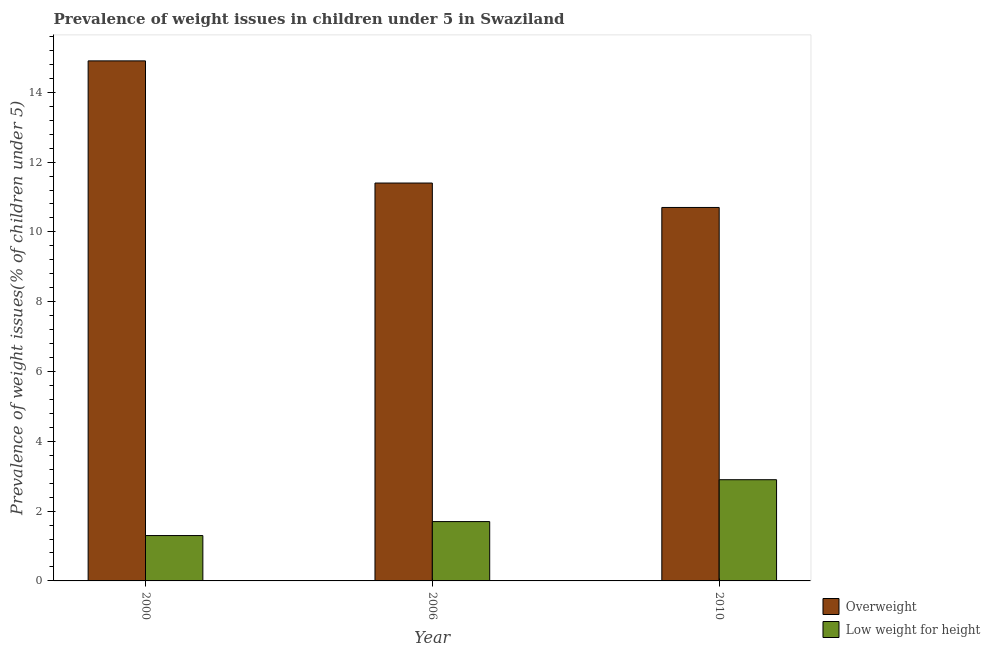How many groups of bars are there?
Offer a terse response. 3. How many bars are there on the 1st tick from the left?
Offer a very short reply. 2. In how many cases, is the number of bars for a given year not equal to the number of legend labels?
Your answer should be compact. 0. What is the percentage of underweight children in 2006?
Your response must be concise. 1.7. Across all years, what is the maximum percentage of underweight children?
Give a very brief answer. 2.9. Across all years, what is the minimum percentage of overweight children?
Give a very brief answer. 10.7. What is the total percentage of underweight children in the graph?
Keep it short and to the point. 5.9. What is the difference between the percentage of overweight children in 2000 and that in 2010?
Keep it short and to the point. 4.2. What is the difference between the percentage of overweight children in 2010 and the percentage of underweight children in 2006?
Your answer should be compact. -0.7. What is the average percentage of overweight children per year?
Provide a short and direct response. 12.33. In how many years, is the percentage of underweight children greater than 10 %?
Offer a very short reply. 0. What is the ratio of the percentage of underweight children in 2006 to that in 2010?
Give a very brief answer. 0.59. Is the percentage of underweight children in 2000 less than that in 2010?
Provide a succinct answer. Yes. Is the difference between the percentage of underweight children in 2000 and 2006 greater than the difference between the percentage of overweight children in 2000 and 2006?
Give a very brief answer. No. What is the difference between the highest and the second highest percentage of underweight children?
Your answer should be compact. 1.2. What is the difference between the highest and the lowest percentage of underweight children?
Provide a succinct answer. 1.6. Is the sum of the percentage of overweight children in 2006 and 2010 greater than the maximum percentage of underweight children across all years?
Your answer should be compact. Yes. What does the 2nd bar from the left in 2000 represents?
Your response must be concise. Low weight for height. What does the 2nd bar from the right in 2010 represents?
Your response must be concise. Overweight. Are all the bars in the graph horizontal?
Make the answer very short. No. How many years are there in the graph?
Your answer should be compact. 3. What is the difference between two consecutive major ticks on the Y-axis?
Make the answer very short. 2. Where does the legend appear in the graph?
Your answer should be very brief. Bottom right. How are the legend labels stacked?
Offer a terse response. Vertical. What is the title of the graph?
Your response must be concise. Prevalence of weight issues in children under 5 in Swaziland. What is the label or title of the Y-axis?
Ensure brevity in your answer.  Prevalence of weight issues(% of children under 5). What is the Prevalence of weight issues(% of children under 5) in Overweight in 2000?
Offer a very short reply. 14.9. What is the Prevalence of weight issues(% of children under 5) of Low weight for height in 2000?
Ensure brevity in your answer.  1.3. What is the Prevalence of weight issues(% of children under 5) in Overweight in 2006?
Give a very brief answer. 11.4. What is the Prevalence of weight issues(% of children under 5) of Low weight for height in 2006?
Your answer should be compact. 1.7. What is the Prevalence of weight issues(% of children under 5) in Overweight in 2010?
Offer a very short reply. 10.7. What is the Prevalence of weight issues(% of children under 5) in Low weight for height in 2010?
Provide a succinct answer. 2.9. Across all years, what is the maximum Prevalence of weight issues(% of children under 5) in Overweight?
Provide a succinct answer. 14.9. Across all years, what is the maximum Prevalence of weight issues(% of children under 5) in Low weight for height?
Make the answer very short. 2.9. Across all years, what is the minimum Prevalence of weight issues(% of children under 5) of Overweight?
Ensure brevity in your answer.  10.7. Across all years, what is the minimum Prevalence of weight issues(% of children under 5) of Low weight for height?
Ensure brevity in your answer.  1.3. What is the difference between the Prevalence of weight issues(% of children under 5) in Low weight for height in 2000 and that in 2006?
Your answer should be compact. -0.4. What is the difference between the Prevalence of weight issues(% of children under 5) of Low weight for height in 2000 and that in 2010?
Offer a terse response. -1.6. What is the difference between the Prevalence of weight issues(% of children under 5) of Overweight in 2006 and that in 2010?
Offer a terse response. 0.7. What is the difference between the Prevalence of weight issues(% of children under 5) in Overweight in 2000 and the Prevalence of weight issues(% of children under 5) in Low weight for height in 2006?
Make the answer very short. 13.2. What is the difference between the Prevalence of weight issues(% of children under 5) of Overweight in 2000 and the Prevalence of weight issues(% of children under 5) of Low weight for height in 2010?
Your answer should be compact. 12. What is the difference between the Prevalence of weight issues(% of children under 5) of Overweight in 2006 and the Prevalence of weight issues(% of children under 5) of Low weight for height in 2010?
Keep it short and to the point. 8.5. What is the average Prevalence of weight issues(% of children under 5) in Overweight per year?
Your response must be concise. 12.33. What is the average Prevalence of weight issues(% of children under 5) of Low weight for height per year?
Offer a terse response. 1.97. In the year 2000, what is the difference between the Prevalence of weight issues(% of children under 5) of Overweight and Prevalence of weight issues(% of children under 5) of Low weight for height?
Keep it short and to the point. 13.6. In the year 2006, what is the difference between the Prevalence of weight issues(% of children under 5) in Overweight and Prevalence of weight issues(% of children under 5) in Low weight for height?
Provide a short and direct response. 9.7. In the year 2010, what is the difference between the Prevalence of weight issues(% of children under 5) in Overweight and Prevalence of weight issues(% of children under 5) in Low weight for height?
Make the answer very short. 7.8. What is the ratio of the Prevalence of weight issues(% of children under 5) of Overweight in 2000 to that in 2006?
Make the answer very short. 1.31. What is the ratio of the Prevalence of weight issues(% of children under 5) in Low weight for height in 2000 to that in 2006?
Your answer should be very brief. 0.76. What is the ratio of the Prevalence of weight issues(% of children under 5) of Overweight in 2000 to that in 2010?
Keep it short and to the point. 1.39. What is the ratio of the Prevalence of weight issues(% of children under 5) in Low weight for height in 2000 to that in 2010?
Keep it short and to the point. 0.45. What is the ratio of the Prevalence of weight issues(% of children under 5) in Overweight in 2006 to that in 2010?
Keep it short and to the point. 1.07. What is the ratio of the Prevalence of weight issues(% of children under 5) in Low weight for height in 2006 to that in 2010?
Offer a very short reply. 0.59. What is the difference between the highest and the second highest Prevalence of weight issues(% of children under 5) of Overweight?
Provide a succinct answer. 3.5. What is the difference between the highest and the second highest Prevalence of weight issues(% of children under 5) in Low weight for height?
Ensure brevity in your answer.  1.2. What is the difference between the highest and the lowest Prevalence of weight issues(% of children under 5) of Overweight?
Ensure brevity in your answer.  4.2. What is the difference between the highest and the lowest Prevalence of weight issues(% of children under 5) in Low weight for height?
Offer a terse response. 1.6. 